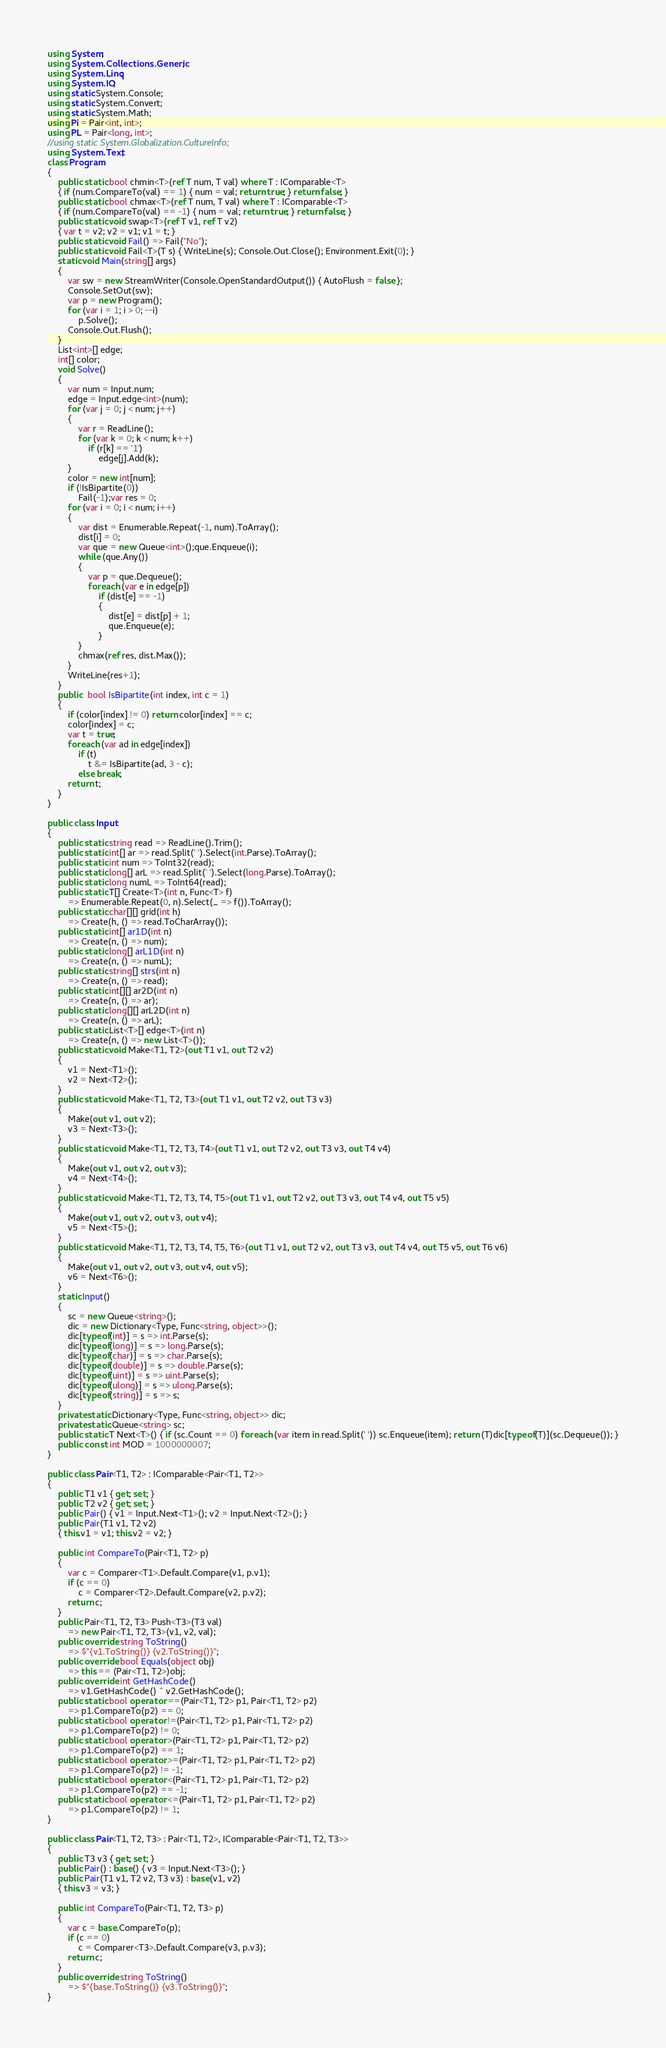<code> <loc_0><loc_0><loc_500><loc_500><_C#_>using System;
using System.Collections.Generic;
using System.Linq;
using System.IO;
using static System.Console;
using static System.Convert;
using static System.Math;
using Pi = Pair<int, int>;
using PL = Pair<long, int>;
//using static System.Globalization.CultureInfo;
using System.Text;
class Program
{
    public static bool chmin<T>(ref T num, T val) where T : IComparable<T>
    { if (num.CompareTo(val) == 1) { num = val; return true; } return false; }
    public static bool chmax<T>(ref T num, T val) where T : IComparable<T>
    { if (num.CompareTo(val) == -1) { num = val; return true; } return false; }
    public static void swap<T>(ref T v1, ref T v2)
    { var t = v2; v2 = v1; v1 = t; }
    public static void Fail() => Fail("No");
    public static void Fail<T>(T s) { WriteLine(s); Console.Out.Close(); Environment.Exit(0); }
    static void Main(string[] args)
    {
        var sw = new StreamWriter(Console.OpenStandardOutput()) { AutoFlush = false };
        Console.SetOut(sw);
        var p = new Program();
        for (var i = 1; i > 0; --i)
            p.Solve();
        Console.Out.Flush();
    }
    List<int>[] edge;
    int[] color;
    void Solve()
    {
        var num = Input.num;
        edge = Input.edge<int>(num);
        for (var j = 0; j < num; j++)
        {
            var r = ReadLine();
            for (var k = 0; k < num; k++)
                if (r[k] == '1')
                    edge[j].Add(k);
        }
        color = new int[num];
        if (!IsBipartite(0))
            Fail(-1);var res = 0;
        for (var i = 0; i < num; i++)
        {
            var dist = Enumerable.Repeat(-1, num).ToArray();
            dist[i] = 0;
            var que = new Queue<int>();que.Enqueue(i);
            while (que.Any())
            {
                var p = que.Dequeue();
                foreach (var e in edge[p])
                    if (dist[e] == -1)
                    {
                        dist[e] = dist[p] + 1;
                        que.Enqueue(e);
                    }
            }
            chmax(ref res, dist.Max());
        }
        WriteLine(res+1);
    }
    public  bool IsBipartite(int index, int c = 1)
    {
        if (color[index] != 0) return color[index] == c;
        color[index] = c;
        var t = true;
        foreach (var ad in edge[index])
            if (t)
                t &= IsBipartite(ad, 3 - c);
            else break;
        return t;
    }
}

public class Input
{
    public static string read => ReadLine().Trim();
    public static int[] ar => read.Split(' ').Select(int.Parse).ToArray();
    public static int num => ToInt32(read);
    public static long[] arL => read.Split(' ').Select(long.Parse).ToArray();
    public static long numL => ToInt64(read);
    public static T[] Create<T>(int n, Func<T> f)
        => Enumerable.Repeat(0, n).Select(_ => f()).ToArray();
    public static char[][] grid(int h)
        => Create(h, () => read.ToCharArray());
    public static int[] ar1D(int n)
        => Create(n, () => num);
    public static long[] arL1D(int n)
        => Create(n, () => numL);
    public static string[] strs(int n)
        => Create(n, () => read);
    public static int[][] ar2D(int n)
        => Create(n, () => ar);
    public static long[][] arL2D(int n)
        => Create(n, () => arL);
    public static List<T>[] edge<T>(int n)
        => Create(n, () => new List<T>());
    public static void Make<T1, T2>(out T1 v1, out T2 v2)
    {
        v1 = Next<T1>();
        v2 = Next<T2>();
    }
    public static void Make<T1, T2, T3>(out T1 v1, out T2 v2, out T3 v3)
    {
        Make(out v1, out v2);
        v3 = Next<T3>();
    }
    public static void Make<T1, T2, T3, T4>(out T1 v1, out T2 v2, out T3 v3, out T4 v4)
    {
        Make(out v1, out v2, out v3);
        v4 = Next<T4>();
    }
    public static void Make<T1, T2, T3, T4, T5>(out T1 v1, out T2 v2, out T3 v3, out T4 v4, out T5 v5)
    {
        Make(out v1, out v2, out v3, out v4);
        v5 = Next<T5>();
    }
    public static void Make<T1, T2, T3, T4, T5, T6>(out T1 v1, out T2 v2, out T3 v3, out T4 v4, out T5 v5, out T6 v6)
    {
        Make(out v1, out v2, out v3, out v4, out v5);
        v6 = Next<T6>();
    }
    static Input()
    {
        sc = new Queue<string>();
        dic = new Dictionary<Type, Func<string, object>>();
        dic[typeof(int)] = s => int.Parse(s);
        dic[typeof(long)] = s => long.Parse(s);
        dic[typeof(char)] = s => char.Parse(s);
        dic[typeof(double)] = s => double.Parse(s);
        dic[typeof(uint)] = s => uint.Parse(s);
        dic[typeof(ulong)] = s => ulong.Parse(s);
        dic[typeof(string)] = s => s;
    }
    private static Dictionary<Type, Func<string, object>> dic;
    private static Queue<string> sc;
    public static T Next<T>() { if (sc.Count == 0) foreach (var item in read.Split(' ')) sc.Enqueue(item); return (T)dic[typeof(T)](sc.Dequeue()); }
    public const int MOD = 1000000007;
}

public class Pair<T1, T2> : IComparable<Pair<T1, T2>>
{
    public T1 v1 { get; set; }
    public T2 v2 { get; set; }
    public Pair() { v1 = Input.Next<T1>(); v2 = Input.Next<T2>(); }
    public Pair(T1 v1, T2 v2)
    { this.v1 = v1; this.v2 = v2; }

    public int CompareTo(Pair<T1, T2> p)
    {
        var c = Comparer<T1>.Default.Compare(v1, p.v1);
        if (c == 0)
            c = Comparer<T2>.Default.Compare(v2, p.v2);
        return c;
    }
    public Pair<T1, T2, T3> Push<T3>(T3 val)
        => new Pair<T1, T2, T3>(v1, v2, val);
    public override string ToString()
        => $"{v1.ToString()} {v2.ToString()}";
    public override bool Equals(object obj)
        => this == (Pair<T1, T2>)obj;
    public override int GetHashCode()
        => v1.GetHashCode() ^ v2.GetHashCode();
    public static bool operator ==(Pair<T1, T2> p1, Pair<T1, T2> p2)
        => p1.CompareTo(p2) == 0;
    public static bool operator !=(Pair<T1, T2> p1, Pair<T1, T2> p2)
        => p1.CompareTo(p2) != 0;
    public static bool operator >(Pair<T1, T2> p1, Pair<T1, T2> p2)
        => p1.CompareTo(p2) == 1;
    public static bool operator >=(Pair<T1, T2> p1, Pair<T1, T2> p2)
        => p1.CompareTo(p2) != -1;
    public static bool operator <(Pair<T1, T2> p1, Pair<T1, T2> p2)
        => p1.CompareTo(p2) == -1;
    public static bool operator <=(Pair<T1, T2> p1, Pair<T1, T2> p2)
        => p1.CompareTo(p2) != 1;
}

public class Pair<T1, T2, T3> : Pair<T1, T2>, IComparable<Pair<T1, T2, T3>>
{
    public T3 v3 { get; set; }
    public Pair() : base() { v3 = Input.Next<T3>(); }
    public Pair(T1 v1, T2 v2, T3 v3) : base(v1, v2)
    { this.v3 = v3; }

    public int CompareTo(Pair<T1, T2, T3> p)
    {
        var c = base.CompareTo(p);
        if (c == 0)
            c = Comparer<T3>.Default.Compare(v3, p.v3);
        return c;
    }
    public override string ToString()
        => $"{base.ToString()} {v3.ToString()}";
}
</code> 